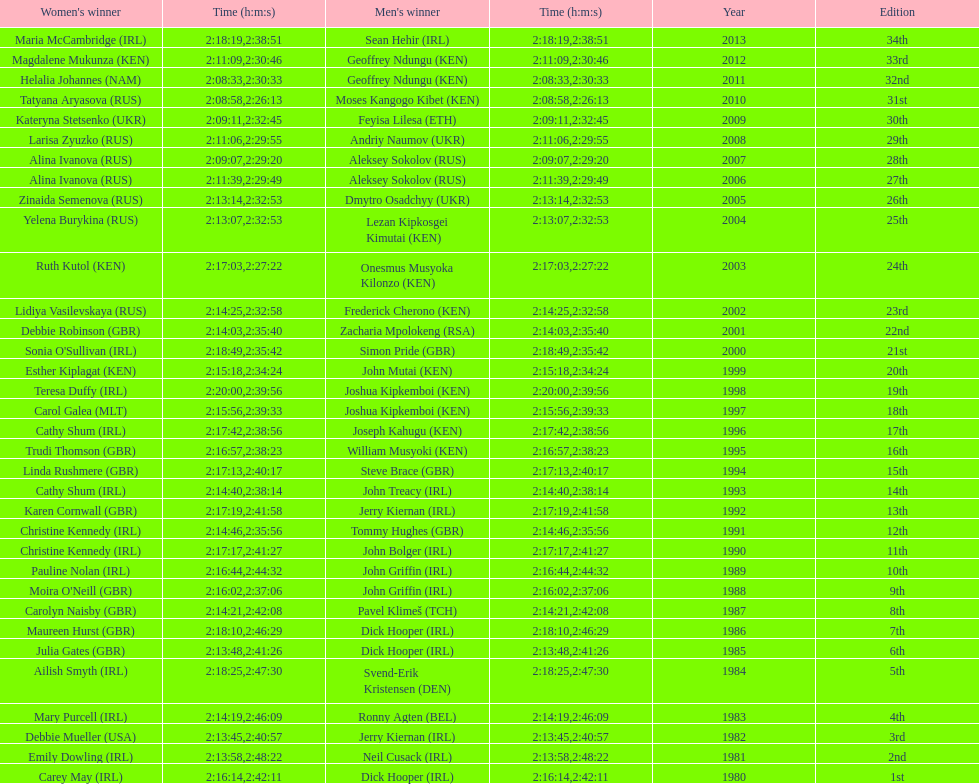Which country is represented for both men and women at the top of the list? Ireland. 